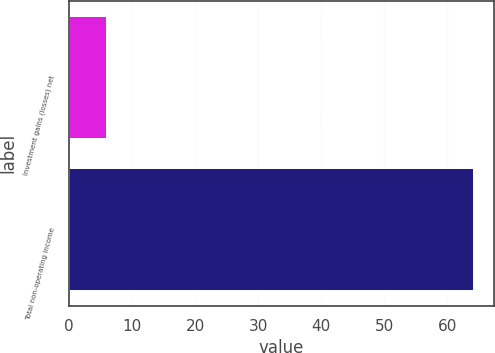<chart> <loc_0><loc_0><loc_500><loc_500><bar_chart><fcel>Investment gains (losses) net<fcel>Total non-operating income<nl><fcel>5.9<fcel>64.1<nl></chart> 